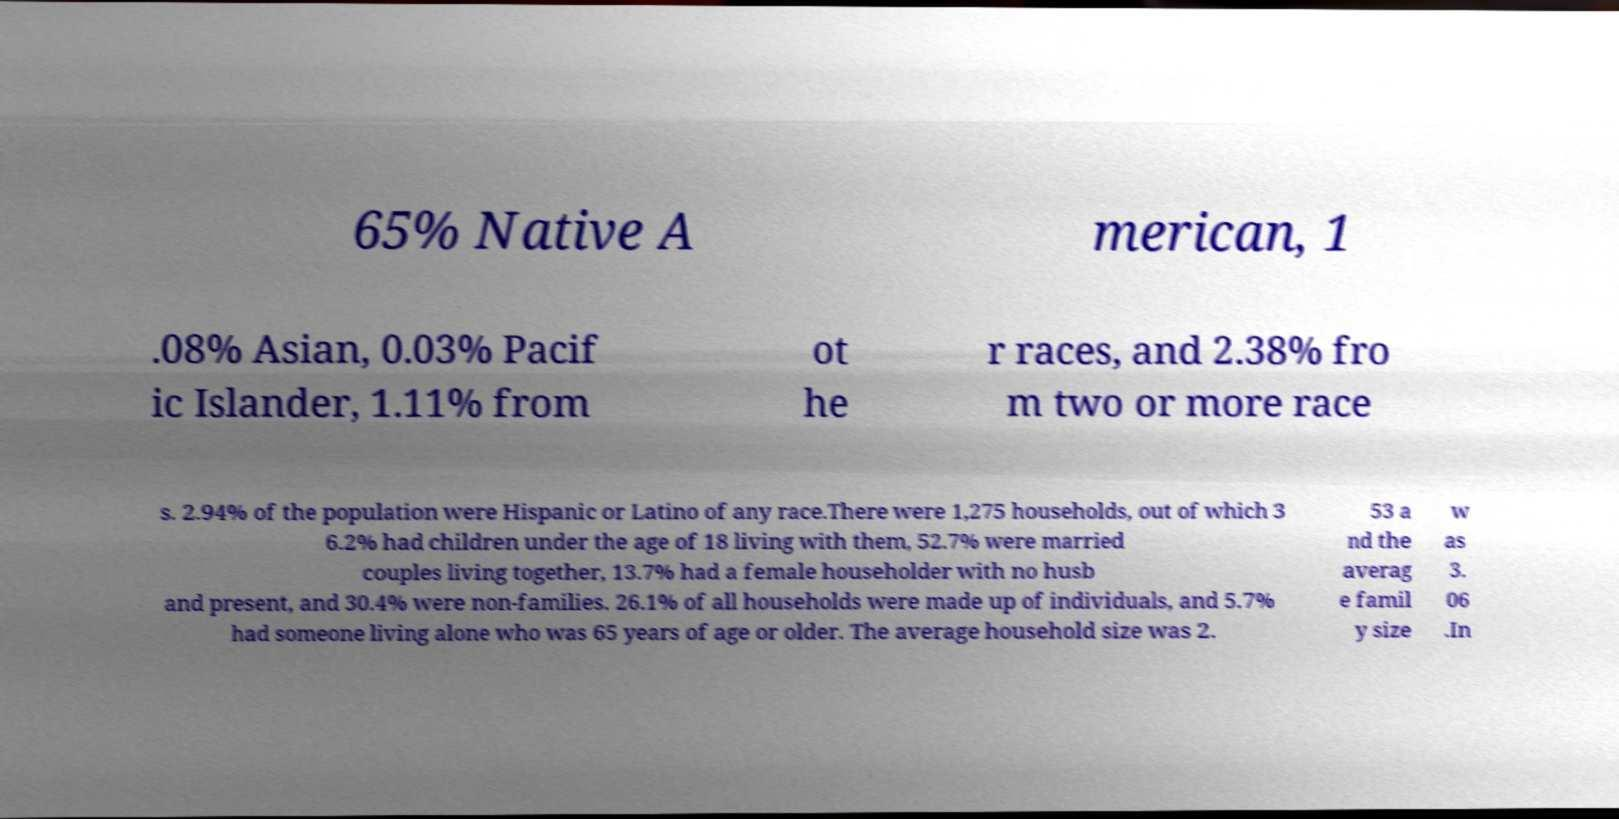Could you extract and type out the text from this image? 65% Native A merican, 1 .08% Asian, 0.03% Pacif ic Islander, 1.11% from ot he r races, and 2.38% fro m two or more race s. 2.94% of the population were Hispanic or Latino of any race.There were 1,275 households, out of which 3 6.2% had children under the age of 18 living with them, 52.7% were married couples living together, 13.7% had a female householder with no husb and present, and 30.4% were non-families. 26.1% of all households were made up of individuals, and 5.7% had someone living alone who was 65 years of age or older. The average household size was 2. 53 a nd the averag e famil y size w as 3. 06 .In 